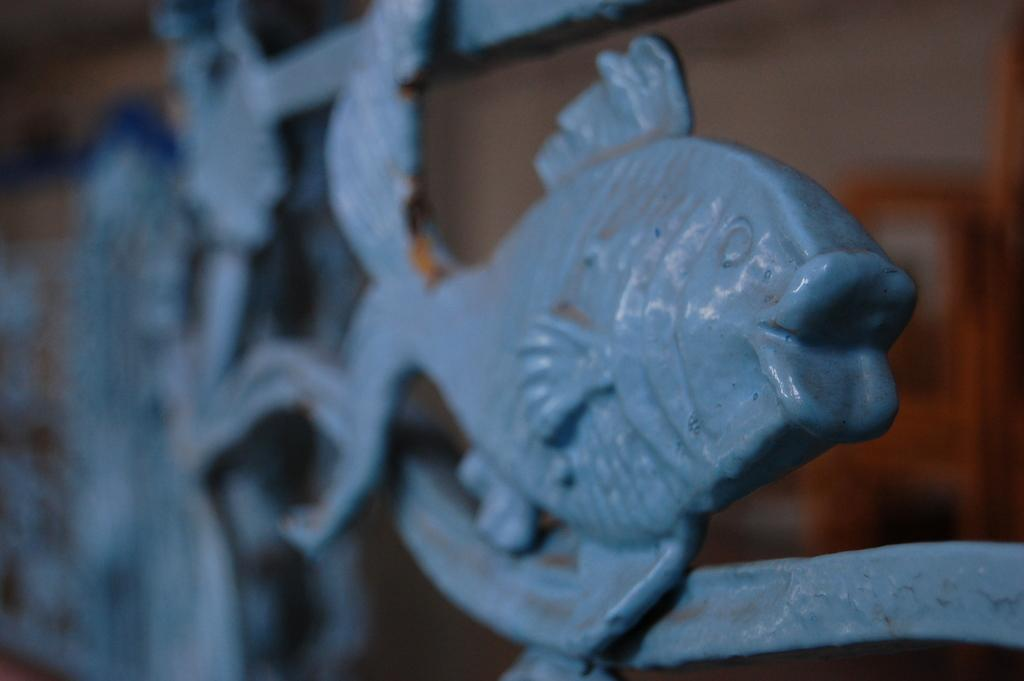What is the main subject of the image? There is a sculpture of a fish in the image. Can you describe the background of the image? The background of the image is blurred. What type of substance is the clover made of in the image? There is no clover present in the image, so it is not possible to determine what substance it might be made of. 